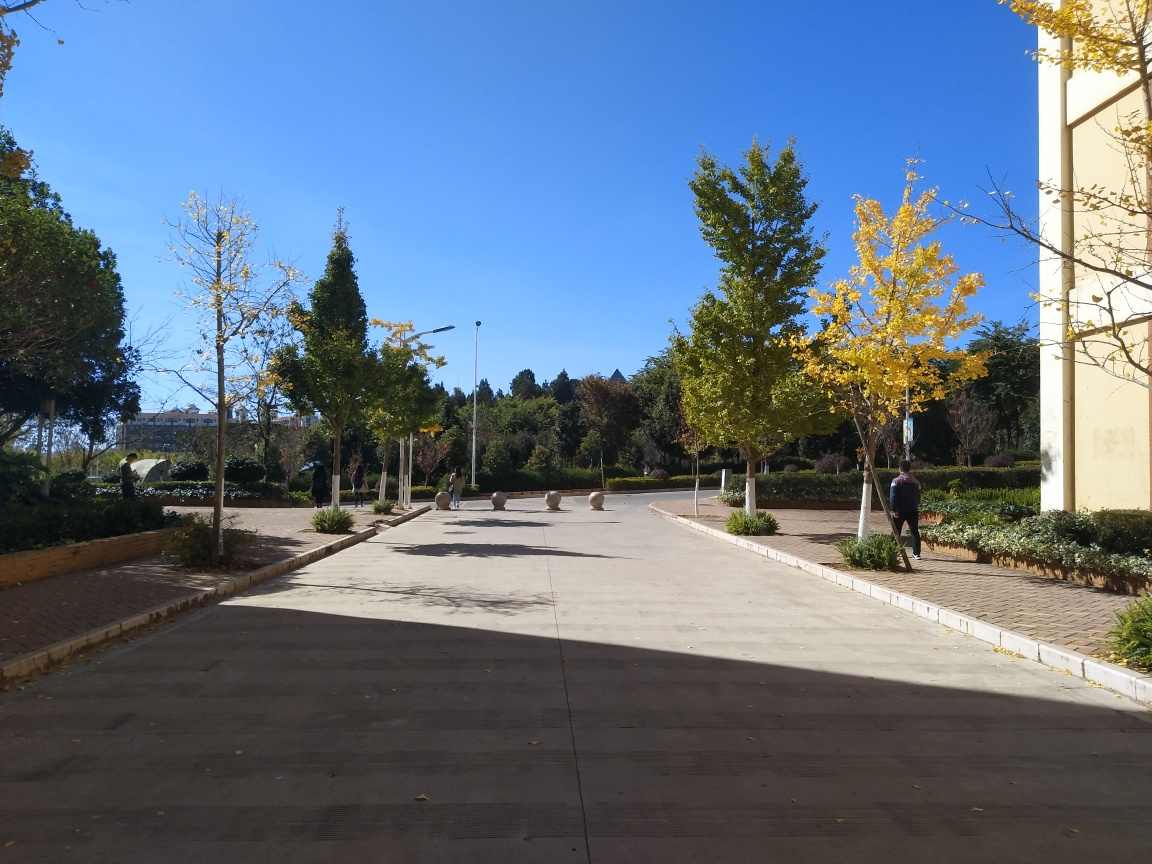Is the overall sharpness of the image high? The image is relatively sharp, displaying clear details in both the foreground and the background, with well-defined leaves on the trees and distinct shadows on the ground. However, considering the highest standards of image sharpness, this image may slightly lack in rendering the finest details, for instance, the texture of the tree bark and the foliage, as well as the architectural details of the distant building. 